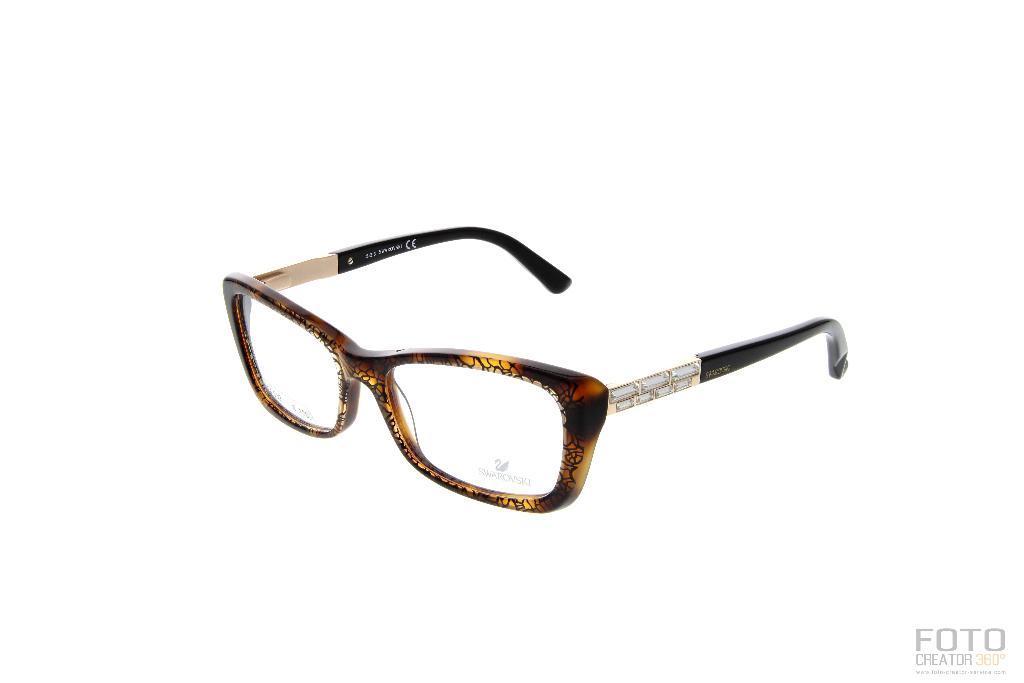Please provide a concise description of this image. In this picture we can see a spectacle and in the background we can see white color. 